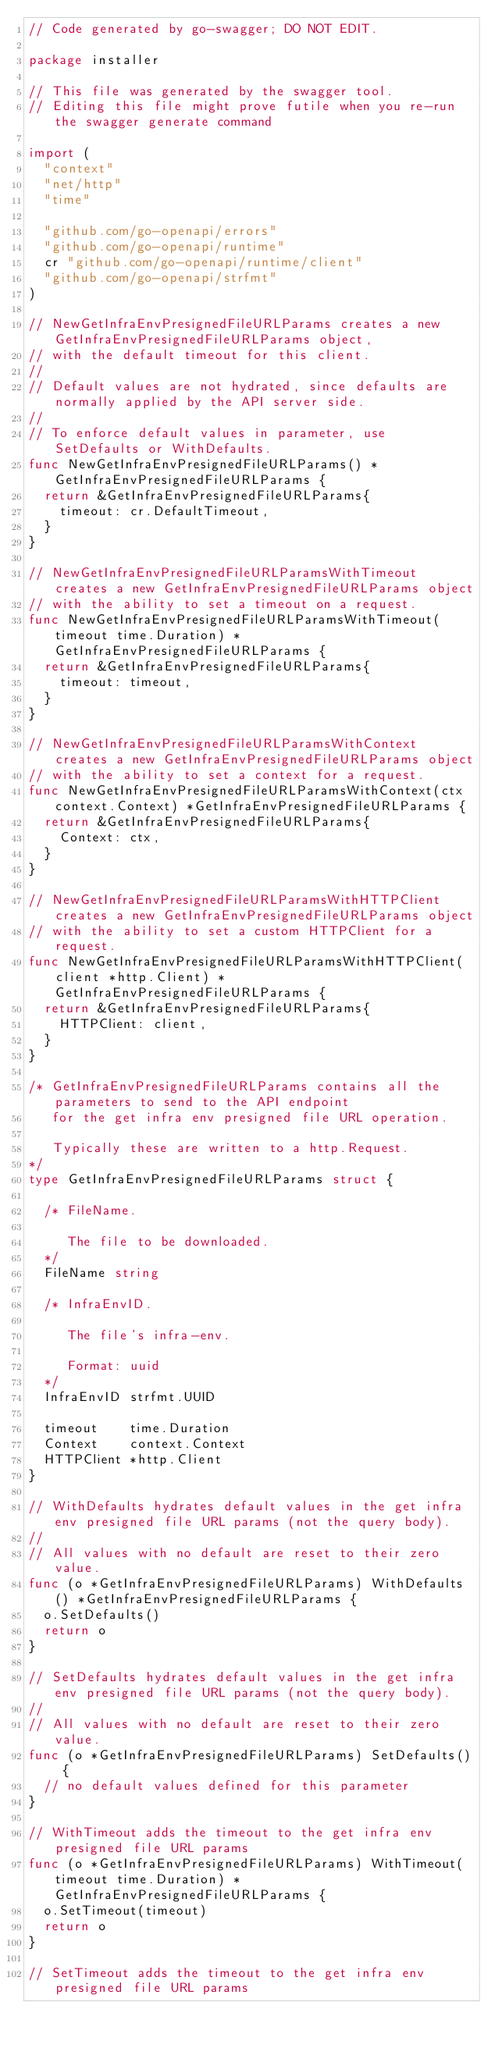<code> <loc_0><loc_0><loc_500><loc_500><_Go_>// Code generated by go-swagger; DO NOT EDIT.

package installer

// This file was generated by the swagger tool.
// Editing this file might prove futile when you re-run the swagger generate command

import (
	"context"
	"net/http"
	"time"

	"github.com/go-openapi/errors"
	"github.com/go-openapi/runtime"
	cr "github.com/go-openapi/runtime/client"
	"github.com/go-openapi/strfmt"
)

// NewGetInfraEnvPresignedFileURLParams creates a new GetInfraEnvPresignedFileURLParams object,
// with the default timeout for this client.
//
// Default values are not hydrated, since defaults are normally applied by the API server side.
//
// To enforce default values in parameter, use SetDefaults or WithDefaults.
func NewGetInfraEnvPresignedFileURLParams() *GetInfraEnvPresignedFileURLParams {
	return &GetInfraEnvPresignedFileURLParams{
		timeout: cr.DefaultTimeout,
	}
}

// NewGetInfraEnvPresignedFileURLParamsWithTimeout creates a new GetInfraEnvPresignedFileURLParams object
// with the ability to set a timeout on a request.
func NewGetInfraEnvPresignedFileURLParamsWithTimeout(timeout time.Duration) *GetInfraEnvPresignedFileURLParams {
	return &GetInfraEnvPresignedFileURLParams{
		timeout: timeout,
	}
}

// NewGetInfraEnvPresignedFileURLParamsWithContext creates a new GetInfraEnvPresignedFileURLParams object
// with the ability to set a context for a request.
func NewGetInfraEnvPresignedFileURLParamsWithContext(ctx context.Context) *GetInfraEnvPresignedFileURLParams {
	return &GetInfraEnvPresignedFileURLParams{
		Context: ctx,
	}
}

// NewGetInfraEnvPresignedFileURLParamsWithHTTPClient creates a new GetInfraEnvPresignedFileURLParams object
// with the ability to set a custom HTTPClient for a request.
func NewGetInfraEnvPresignedFileURLParamsWithHTTPClient(client *http.Client) *GetInfraEnvPresignedFileURLParams {
	return &GetInfraEnvPresignedFileURLParams{
		HTTPClient: client,
	}
}

/* GetInfraEnvPresignedFileURLParams contains all the parameters to send to the API endpoint
   for the get infra env presigned file URL operation.

   Typically these are written to a http.Request.
*/
type GetInfraEnvPresignedFileURLParams struct {

	/* FileName.

	   The file to be downloaded.
	*/
	FileName string

	/* InfraEnvID.

	   The file's infra-env.

	   Format: uuid
	*/
	InfraEnvID strfmt.UUID

	timeout    time.Duration
	Context    context.Context
	HTTPClient *http.Client
}

// WithDefaults hydrates default values in the get infra env presigned file URL params (not the query body).
//
// All values with no default are reset to their zero value.
func (o *GetInfraEnvPresignedFileURLParams) WithDefaults() *GetInfraEnvPresignedFileURLParams {
	o.SetDefaults()
	return o
}

// SetDefaults hydrates default values in the get infra env presigned file URL params (not the query body).
//
// All values with no default are reset to their zero value.
func (o *GetInfraEnvPresignedFileURLParams) SetDefaults() {
	// no default values defined for this parameter
}

// WithTimeout adds the timeout to the get infra env presigned file URL params
func (o *GetInfraEnvPresignedFileURLParams) WithTimeout(timeout time.Duration) *GetInfraEnvPresignedFileURLParams {
	o.SetTimeout(timeout)
	return o
}

// SetTimeout adds the timeout to the get infra env presigned file URL params</code> 